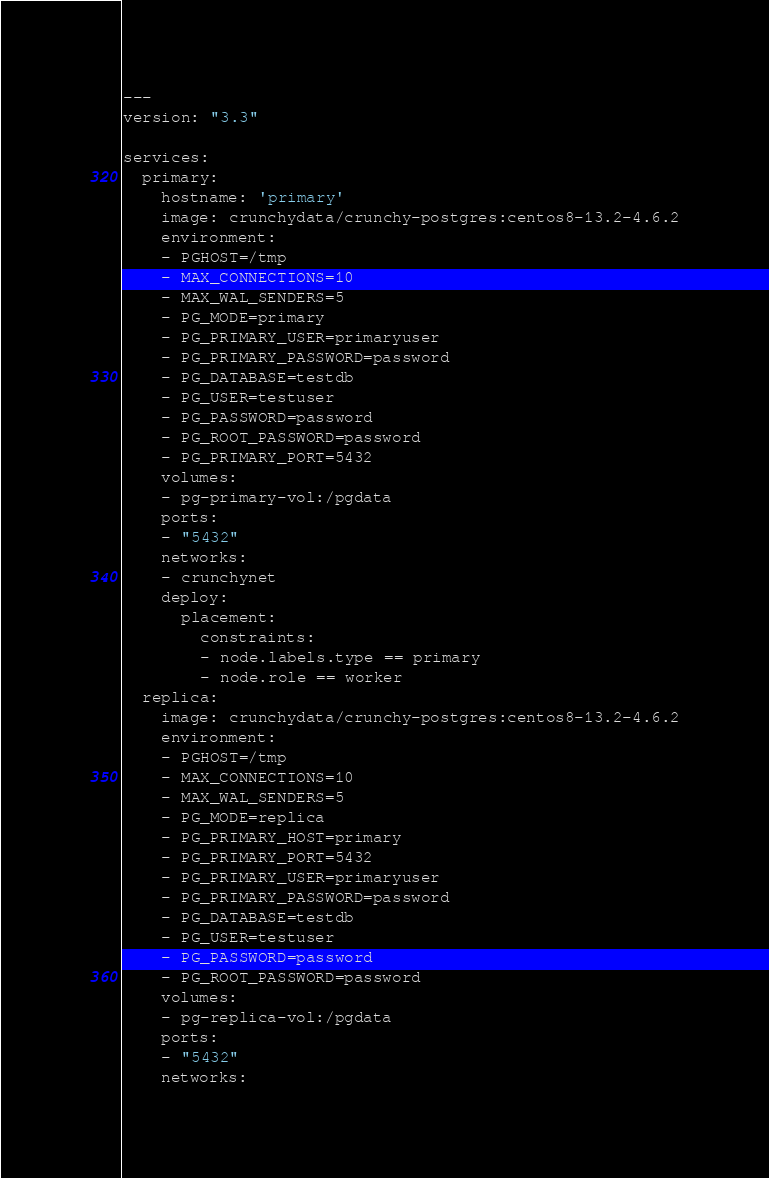Convert code to text. <code><loc_0><loc_0><loc_500><loc_500><_YAML_>---
version: "3.3"

services:
  primary:
    hostname: 'primary'
    image: crunchydata/crunchy-postgres:centos8-13.2-4.6.2
    environment:
    - PGHOST=/tmp
    - MAX_CONNECTIONS=10
    - MAX_WAL_SENDERS=5
    - PG_MODE=primary
    - PG_PRIMARY_USER=primaryuser
    - PG_PRIMARY_PASSWORD=password
    - PG_DATABASE=testdb
    - PG_USER=testuser
    - PG_PASSWORD=password
    - PG_ROOT_PASSWORD=password
    - PG_PRIMARY_PORT=5432
    volumes:
    - pg-primary-vol:/pgdata
    ports:
    - "5432"
    networks:
    - crunchynet
    deploy:
      placement:
        constraints:
        - node.labels.type == primary
        - node.role == worker
  replica:
    image: crunchydata/crunchy-postgres:centos8-13.2-4.6.2
    environment:
    - PGHOST=/tmp
    - MAX_CONNECTIONS=10
    - MAX_WAL_SENDERS=5
    - PG_MODE=replica
    - PG_PRIMARY_HOST=primary
    - PG_PRIMARY_PORT=5432
    - PG_PRIMARY_USER=primaryuser
    - PG_PRIMARY_PASSWORD=password
    - PG_DATABASE=testdb
    - PG_USER=testuser
    - PG_PASSWORD=password
    - PG_ROOT_PASSWORD=password
    volumes:
    - pg-replica-vol:/pgdata
    ports:
    - "5432"
    networks:</code> 